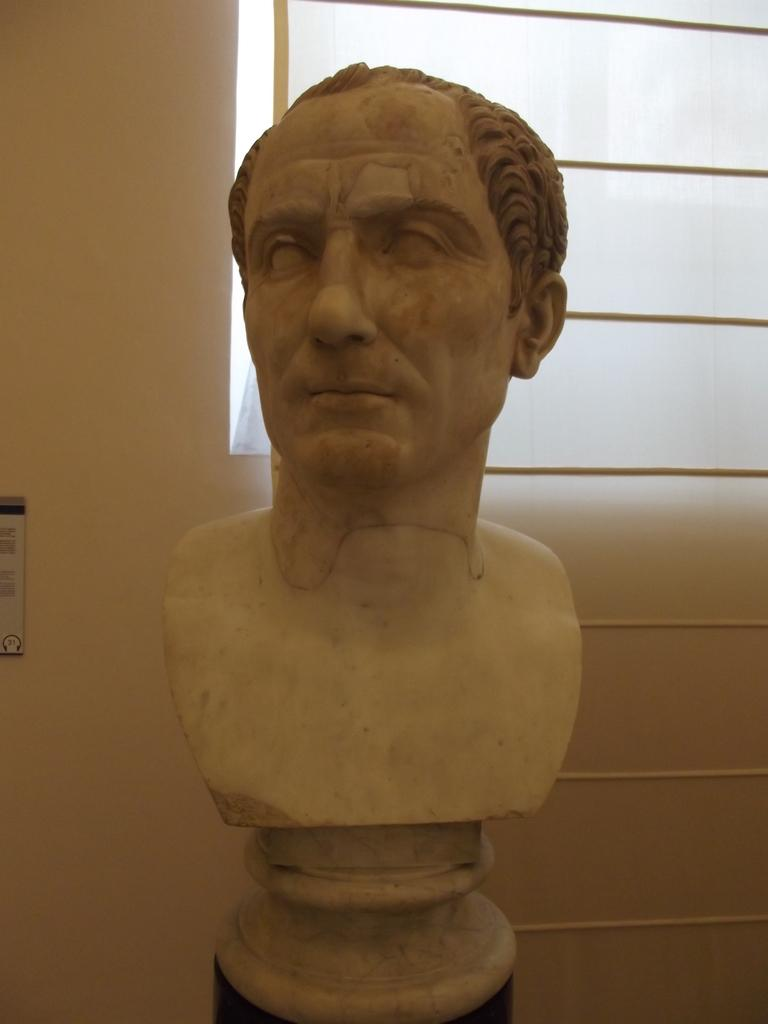What is the main subject of the image? There is a sculpture in the image. What can be seen in the background of the image? There is a window and a wall visible in the image. What type of ear can be seen on the sculpture in the image? There is no ear present on the sculpture in the image. What type of wilderness can be seen through the window in the image? There is no wilderness visible through the window in the image; only the wall is visible. 